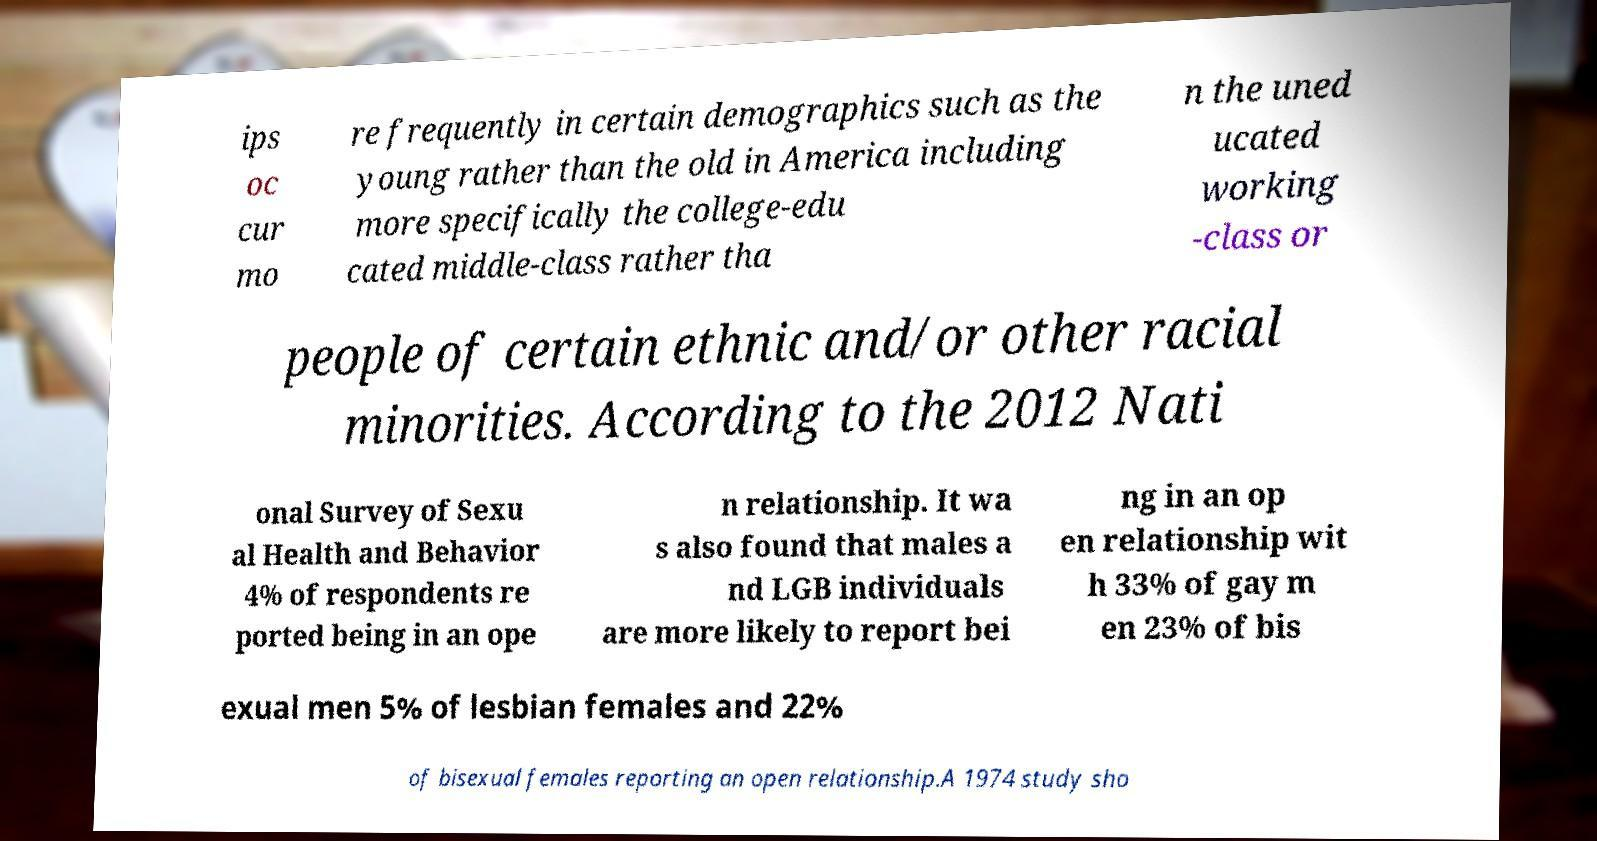Could you assist in decoding the text presented in this image and type it out clearly? ips oc cur mo re frequently in certain demographics such as the young rather than the old in America including more specifically the college-edu cated middle-class rather tha n the uned ucated working -class or people of certain ethnic and/or other racial minorities. According to the 2012 Nati onal Survey of Sexu al Health and Behavior 4% of respondents re ported being in an ope n relationship. It wa s also found that males a nd LGB individuals are more likely to report bei ng in an op en relationship wit h 33% of gay m en 23% of bis exual men 5% of lesbian females and 22% of bisexual females reporting an open relationship.A 1974 study sho 